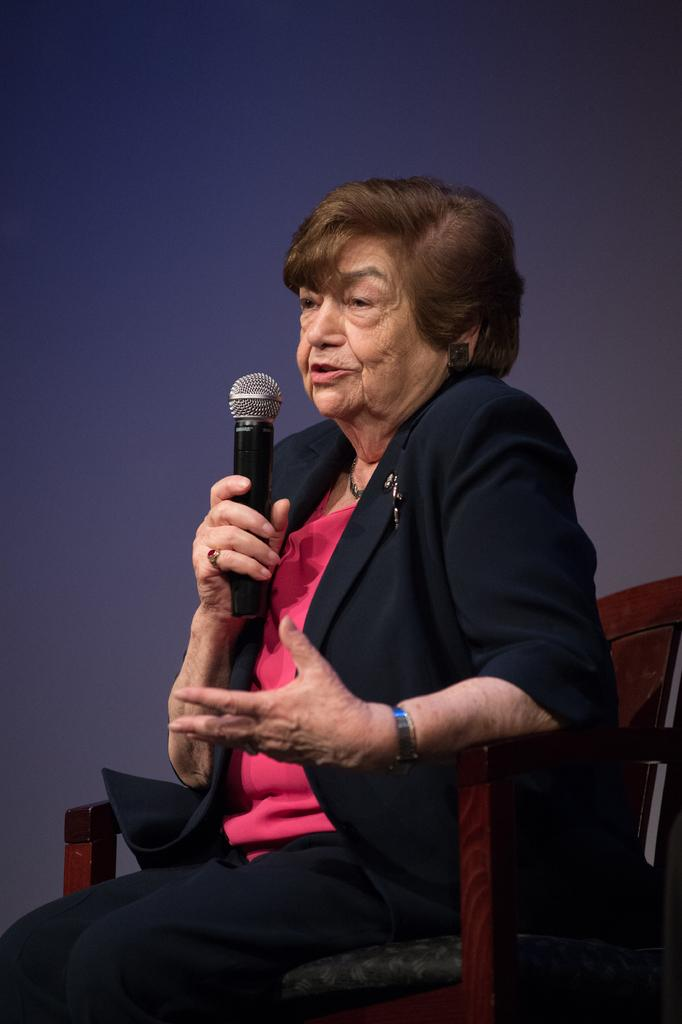Who is the main subject in the image? There is a woman in the image. What is the woman holding in the image? The woman is holding a microphone. What is the woman's position in the image? The woman is sitting in a chair. What type of tin can be seen on the train in the image? There is no train or tin present in the image; it features a woman sitting in a chair holding a microphone. 